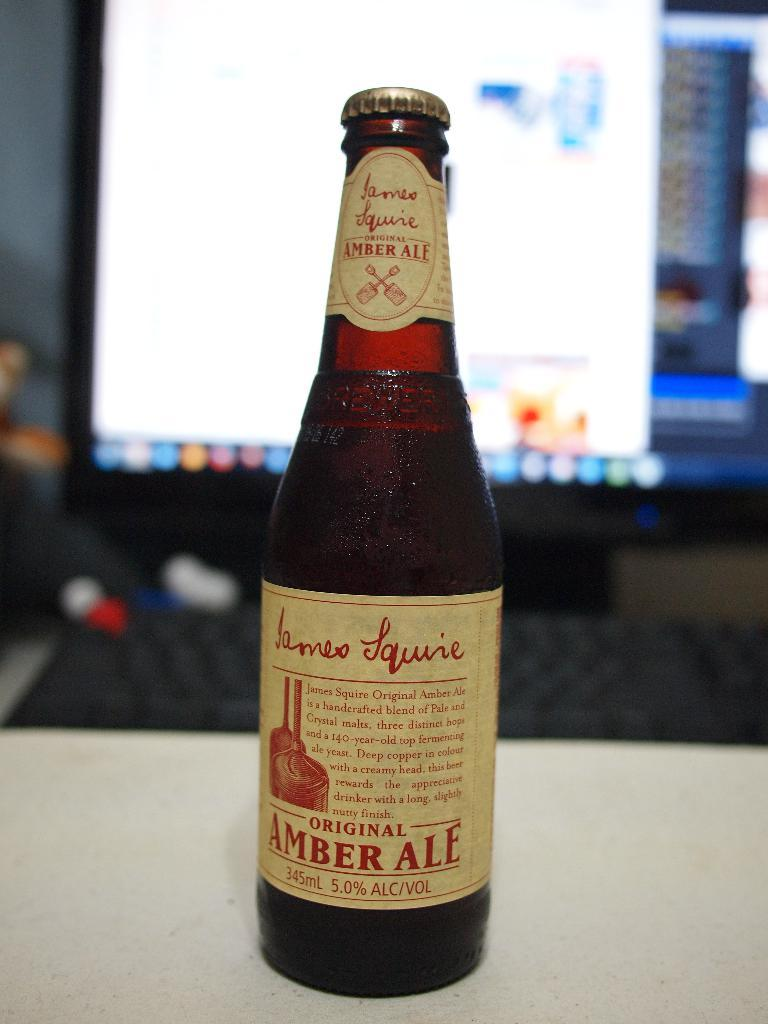<image>
Present a compact description of the photo's key features. A bottle of James Squire Original Amber Ale which is handcrafted and holds 345ml with an alcohol content of 5% 